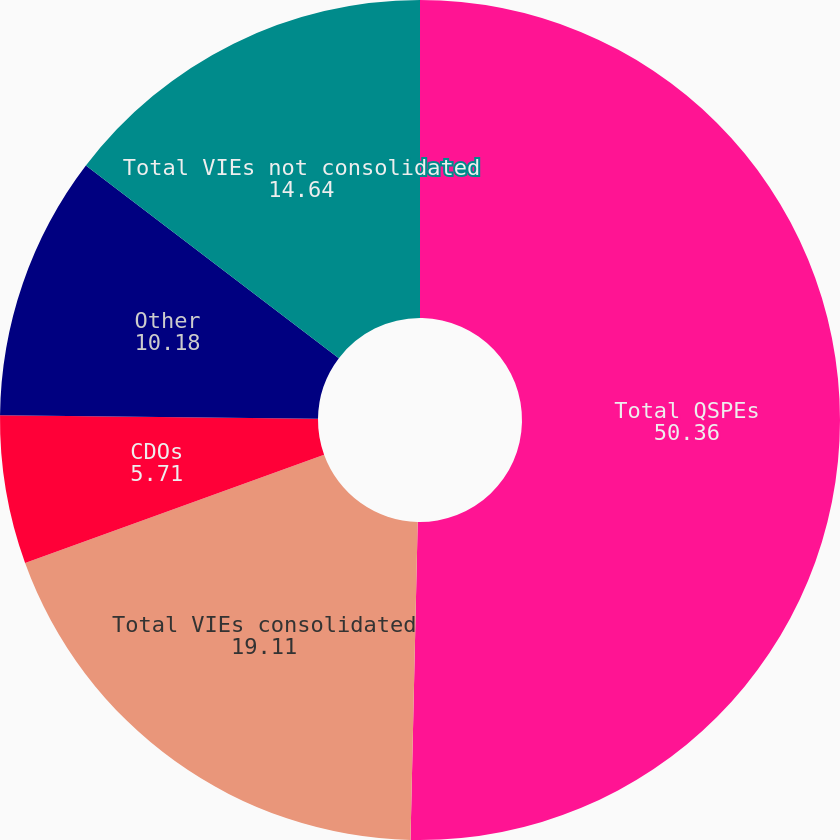Convert chart to OTSL. <chart><loc_0><loc_0><loc_500><loc_500><pie_chart><fcel>Total QSPEs<fcel>Total VIEs consolidated<fcel>CDOs<fcel>Other<fcel>Total VIEs not consolidated<nl><fcel>50.36%<fcel>19.11%<fcel>5.71%<fcel>10.18%<fcel>14.64%<nl></chart> 